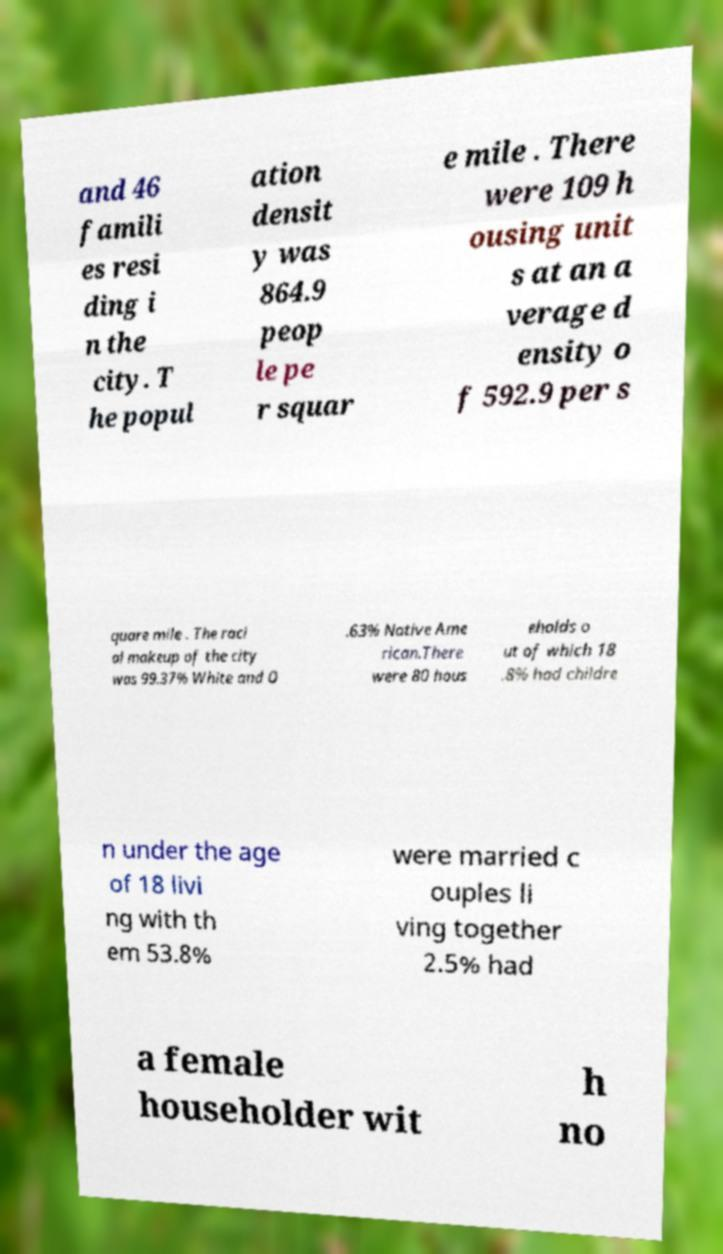For documentation purposes, I need the text within this image transcribed. Could you provide that? and 46 famili es resi ding i n the city. T he popul ation densit y was 864.9 peop le pe r squar e mile . There were 109 h ousing unit s at an a verage d ensity o f 592.9 per s quare mile . The raci al makeup of the city was 99.37% White and 0 .63% Native Ame rican.There were 80 hous eholds o ut of which 18 .8% had childre n under the age of 18 livi ng with th em 53.8% were married c ouples li ving together 2.5% had a female householder wit h no 